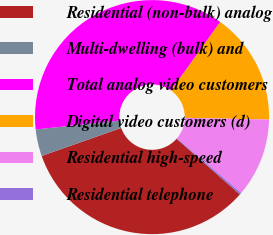Convert chart to OTSL. <chart><loc_0><loc_0><loc_500><loc_500><pie_chart><fcel>Residential (non-bulk) analog<fcel>Multi-dwelling (bulk) and<fcel>Total analog video customers<fcel>Digital video customers (d)<fcel>Residential high-speed<fcel>Residential telephone<nl><fcel>33.14%<fcel>3.7%<fcel>36.58%<fcel>15.44%<fcel>10.88%<fcel>0.26%<nl></chart> 